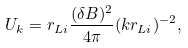<formula> <loc_0><loc_0><loc_500><loc_500>U _ { k } = r _ { L i } \frac { ( \delta B ) ^ { 2 } } { 4 \pi } ( k r _ { L i } ) ^ { - 2 } ,</formula> 